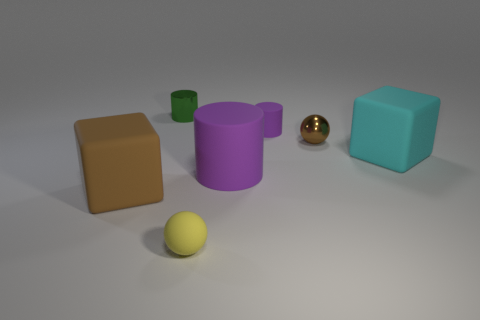Add 1 cyan rubber blocks. How many objects exist? 8 Subtract all blocks. How many objects are left? 5 Add 2 cylinders. How many cylinders are left? 5 Add 4 small purple rubber things. How many small purple rubber things exist? 5 Subtract 0 gray spheres. How many objects are left? 7 Subtract all matte spheres. Subtract all big rubber things. How many objects are left? 3 